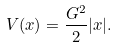Convert formula to latex. <formula><loc_0><loc_0><loc_500><loc_500>V ( x ) = \frac { G ^ { 2 } } { 2 } | x | .</formula> 